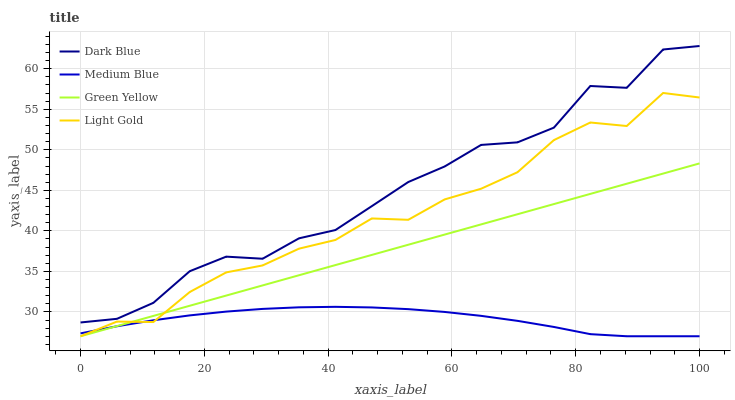Does Medium Blue have the minimum area under the curve?
Answer yes or no. Yes. Does Dark Blue have the maximum area under the curve?
Answer yes or no. Yes. Does Green Yellow have the minimum area under the curve?
Answer yes or no. No. Does Green Yellow have the maximum area under the curve?
Answer yes or no. No. Is Green Yellow the smoothest?
Answer yes or no. Yes. Is Dark Blue the roughest?
Answer yes or no. Yes. Is Medium Blue the smoothest?
Answer yes or no. No. Is Medium Blue the roughest?
Answer yes or no. No. Does Green Yellow have the lowest value?
Answer yes or no. Yes. Does Dark Blue have the highest value?
Answer yes or no. Yes. Does Green Yellow have the highest value?
Answer yes or no. No. Is Green Yellow less than Dark Blue?
Answer yes or no. Yes. Is Dark Blue greater than Light Gold?
Answer yes or no. Yes. Does Light Gold intersect Green Yellow?
Answer yes or no. Yes. Is Light Gold less than Green Yellow?
Answer yes or no. No. Is Light Gold greater than Green Yellow?
Answer yes or no. No. Does Green Yellow intersect Dark Blue?
Answer yes or no. No. 